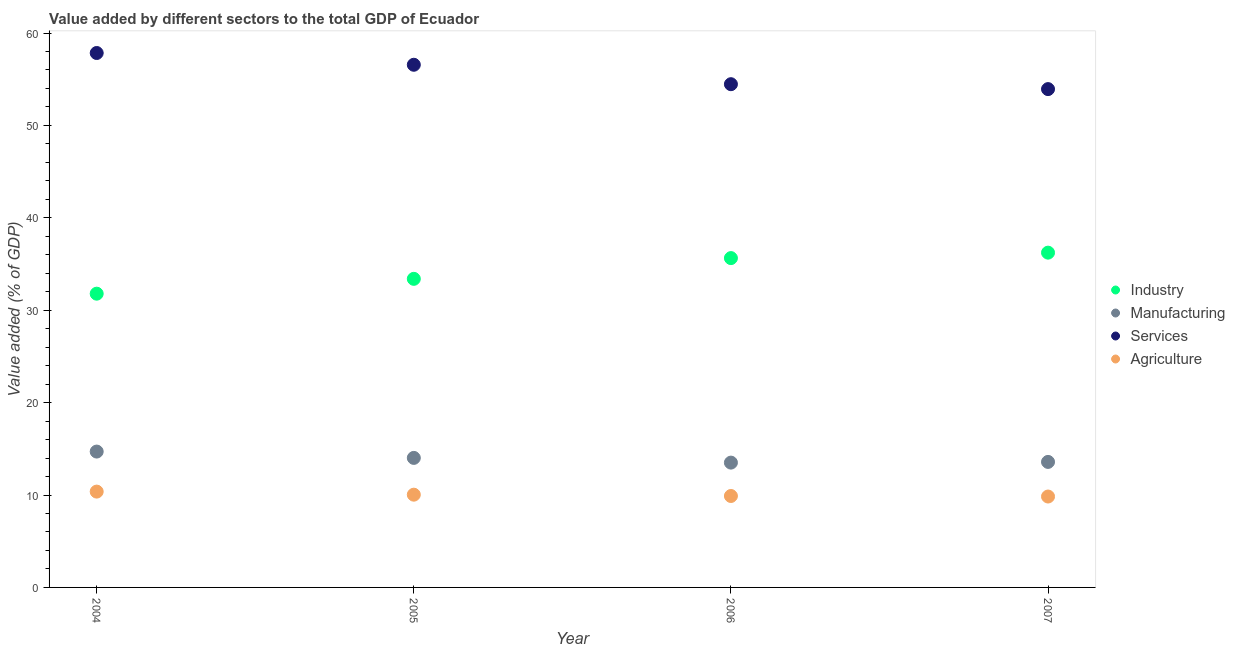What is the value added by agricultural sector in 2004?
Your answer should be compact. 10.37. Across all years, what is the maximum value added by services sector?
Offer a terse response. 57.84. Across all years, what is the minimum value added by agricultural sector?
Offer a very short reply. 9.84. In which year was the value added by services sector maximum?
Offer a terse response. 2004. What is the total value added by services sector in the graph?
Provide a short and direct response. 222.8. What is the difference between the value added by industrial sector in 2004 and that in 2005?
Your answer should be compact. -1.61. What is the difference between the value added by agricultural sector in 2005 and the value added by industrial sector in 2004?
Give a very brief answer. -21.75. What is the average value added by manufacturing sector per year?
Your answer should be compact. 13.95. In the year 2007, what is the difference between the value added by industrial sector and value added by services sector?
Provide a short and direct response. -17.7. In how many years, is the value added by services sector greater than 18 %?
Keep it short and to the point. 4. What is the ratio of the value added by manufacturing sector in 2006 to that in 2007?
Your response must be concise. 0.99. What is the difference between the highest and the second highest value added by manufacturing sector?
Give a very brief answer. 0.69. What is the difference between the highest and the lowest value added by manufacturing sector?
Your answer should be compact. 1.2. In how many years, is the value added by services sector greater than the average value added by services sector taken over all years?
Keep it short and to the point. 2. Is the sum of the value added by services sector in 2004 and 2006 greater than the maximum value added by agricultural sector across all years?
Provide a short and direct response. Yes. Is it the case that in every year, the sum of the value added by manufacturing sector and value added by services sector is greater than the sum of value added by industrial sector and value added by agricultural sector?
Give a very brief answer. No. Is the value added by agricultural sector strictly greater than the value added by manufacturing sector over the years?
Give a very brief answer. No. Is the value added by industrial sector strictly less than the value added by agricultural sector over the years?
Your response must be concise. No. How many years are there in the graph?
Offer a very short reply. 4. Does the graph contain grids?
Make the answer very short. No. How many legend labels are there?
Keep it short and to the point. 4. How are the legend labels stacked?
Keep it short and to the point. Vertical. What is the title of the graph?
Offer a terse response. Value added by different sectors to the total GDP of Ecuador. Does "UNPBF" appear as one of the legend labels in the graph?
Your answer should be compact. No. What is the label or title of the Y-axis?
Provide a succinct answer. Value added (% of GDP). What is the Value added (% of GDP) of Industry in 2004?
Keep it short and to the point. 31.79. What is the Value added (% of GDP) in Manufacturing in 2004?
Your answer should be very brief. 14.7. What is the Value added (% of GDP) of Services in 2004?
Make the answer very short. 57.84. What is the Value added (% of GDP) of Agriculture in 2004?
Give a very brief answer. 10.37. What is the Value added (% of GDP) in Industry in 2005?
Ensure brevity in your answer.  33.4. What is the Value added (% of GDP) in Manufacturing in 2005?
Your answer should be compact. 14.02. What is the Value added (% of GDP) of Services in 2005?
Ensure brevity in your answer.  56.57. What is the Value added (% of GDP) of Agriculture in 2005?
Your answer should be very brief. 10.04. What is the Value added (% of GDP) in Industry in 2006?
Your answer should be very brief. 35.64. What is the Value added (% of GDP) of Manufacturing in 2006?
Make the answer very short. 13.51. What is the Value added (% of GDP) in Services in 2006?
Provide a succinct answer. 54.46. What is the Value added (% of GDP) of Agriculture in 2006?
Provide a short and direct response. 9.9. What is the Value added (% of GDP) in Industry in 2007?
Ensure brevity in your answer.  36.23. What is the Value added (% of GDP) in Manufacturing in 2007?
Provide a succinct answer. 13.58. What is the Value added (% of GDP) of Services in 2007?
Ensure brevity in your answer.  53.93. What is the Value added (% of GDP) of Agriculture in 2007?
Offer a very short reply. 9.84. Across all years, what is the maximum Value added (% of GDP) in Industry?
Your response must be concise. 36.23. Across all years, what is the maximum Value added (% of GDP) of Manufacturing?
Offer a very short reply. 14.7. Across all years, what is the maximum Value added (% of GDP) of Services?
Give a very brief answer. 57.84. Across all years, what is the maximum Value added (% of GDP) in Agriculture?
Your answer should be compact. 10.37. Across all years, what is the minimum Value added (% of GDP) in Industry?
Your answer should be very brief. 31.79. Across all years, what is the minimum Value added (% of GDP) in Manufacturing?
Your answer should be compact. 13.51. Across all years, what is the minimum Value added (% of GDP) of Services?
Your answer should be compact. 53.93. Across all years, what is the minimum Value added (% of GDP) in Agriculture?
Your answer should be very brief. 9.84. What is the total Value added (% of GDP) of Industry in the graph?
Make the answer very short. 137.06. What is the total Value added (% of GDP) of Manufacturing in the graph?
Provide a succinct answer. 55.81. What is the total Value added (% of GDP) of Services in the graph?
Your answer should be very brief. 222.8. What is the total Value added (% of GDP) of Agriculture in the graph?
Keep it short and to the point. 40.14. What is the difference between the Value added (% of GDP) of Industry in 2004 and that in 2005?
Offer a very short reply. -1.61. What is the difference between the Value added (% of GDP) in Manufacturing in 2004 and that in 2005?
Provide a succinct answer. 0.69. What is the difference between the Value added (% of GDP) of Services in 2004 and that in 2005?
Your response must be concise. 1.27. What is the difference between the Value added (% of GDP) of Agriculture in 2004 and that in 2005?
Make the answer very short. 0.33. What is the difference between the Value added (% of GDP) of Industry in 2004 and that in 2006?
Offer a very short reply. -3.85. What is the difference between the Value added (% of GDP) in Manufacturing in 2004 and that in 2006?
Give a very brief answer. 1.2. What is the difference between the Value added (% of GDP) in Services in 2004 and that in 2006?
Give a very brief answer. 3.38. What is the difference between the Value added (% of GDP) of Agriculture in 2004 and that in 2006?
Give a very brief answer. 0.47. What is the difference between the Value added (% of GDP) in Industry in 2004 and that in 2007?
Ensure brevity in your answer.  -4.44. What is the difference between the Value added (% of GDP) in Manufacturing in 2004 and that in 2007?
Offer a terse response. 1.12. What is the difference between the Value added (% of GDP) of Services in 2004 and that in 2007?
Offer a terse response. 3.91. What is the difference between the Value added (% of GDP) in Agriculture in 2004 and that in 2007?
Your answer should be very brief. 0.53. What is the difference between the Value added (% of GDP) in Industry in 2005 and that in 2006?
Give a very brief answer. -2.25. What is the difference between the Value added (% of GDP) of Manufacturing in 2005 and that in 2006?
Ensure brevity in your answer.  0.51. What is the difference between the Value added (% of GDP) in Services in 2005 and that in 2006?
Provide a short and direct response. 2.1. What is the difference between the Value added (% of GDP) in Agriculture in 2005 and that in 2006?
Your answer should be compact. 0.14. What is the difference between the Value added (% of GDP) in Industry in 2005 and that in 2007?
Ensure brevity in your answer.  -2.83. What is the difference between the Value added (% of GDP) in Manufacturing in 2005 and that in 2007?
Make the answer very short. 0.43. What is the difference between the Value added (% of GDP) in Services in 2005 and that in 2007?
Provide a short and direct response. 2.63. What is the difference between the Value added (% of GDP) in Agriculture in 2005 and that in 2007?
Your answer should be compact. 0.2. What is the difference between the Value added (% of GDP) in Industry in 2006 and that in 2007?
Give a very brief answer. -0.59. What is the difference between the Value added (% of GDP) in Manufacturing in 2006 and that in 2007?
Give a very brief answer. -0.08. What is the difference between the Value added (% of GDP) in Services in 2006 and that in 2007?
Offer a very short reply. 0.53. What is the difference between the Value added (% of GDP) in Agriculture in 2006 and that in 2007?
Give a very brief answer. 0.06. What is the difference between the Value added (% of GDP) in Industry in 2004 and the Value added (% of GDP) in Manufacturing in 2005?
Give a very brief answer. 17.77. What is the difference between the Value added (% of GDP) in Industry in 2004 and the Value added (% of GDP) in Services in 2005?
Your answer should be very brief. -24.77. What is the difference between the Value added (% of GDP) in Industry in 2004 and the Value added (% of GDP) in Agriculture in 2005?
Provide a succinct answer. 21.75. What is the difference between the Value added (% of GDP) in Manufacturing in 2004 and the Value added (% of GDP) in Services in 2005?
Your answer should be compact. -41.86. What is the difference between the Value added (% of GDP) of Manufacturing in 2004 and the Value added (% of GDP) of Agriculture in 2005?
Offer a terse response. 4.67. What is the difference between the Value added (% of GDP) in Services in 2004 and the Value added (% of GDP) in Agriculture in 2005?
Offer a terse response. 47.8. What is the difference between the Value added (% of GDP) in Industry in 2004 and the Value added (% of GDP) in Manufacturing in 2006?
Make the answer very short. 18.28. What is the difference between the Value added (% of GDP) of Industry in 2004 and the Value added (% of GDP) of Services in 2006?
Make the answer very short. -22.67. What is the difference between the Value added (% of GDP) of Industry in 2004 and the Value added (% of GDP) of Agriculture in 2006?
Your response must be concise. 21.9. What is the difference between the Value added (% of GDP) in Manufacturing in 2004 and the Value added (% of GDP) in Services in 2006?
Provide a succinct answer. -39.76. What is the difference between the Value added (% of GDP) of Manufacturing in 2004 and the Value added (% of GDP) of Agriculture in 2006?
Keep it short and to the point. 4.81. What is the difference between the Value added (% of GDP) of Services in 2004 and the Value added (% of GDP) of Agriculture in 2006?
Your answer should be compact. 47.94. What is the difference between the Value added (% of GDP) in Industry in 2004 and the Value added (% of GDP) in Manufacturing in 2007?
Make the answer very short. 18.21. What is the difference between the Value added (% of GDP) in Industry in 2004 and the Value added (% of GDP) in Services in 2007?
Provide a succinct answer. -22.14. What is the difference between the Value added (% of GDP) in Industry in 2004 and the Value added (% of GDP) in Agriculture in 2007?
Give a very brief answer. 21.95. What is the difference between the Value added (% of GDP) of Manufacturing in 2004 and the Value added (% of GDP) of Services in 2007?
Provide a short and direct response. -39.23. What is the difference between the Value added (% of GDP) of Manufacturing in 2004 and the Value added (% of GDP) of Agriculture in 2007?
Keep it short and to the point. 4.87. What is the difference between the Value added (% of GDP) in Services in 2004 and the Value added (% of GDP) in Agriculture in 2007?
Ensure brevity in your answer.  48. What is the difference between the Value added (% of GDP) in Industry in 2005 and the Value added (% of GDP) in Manufacturing in 2006?
Offer a terse response. 19.89. What is the difference between the Value added (% of GDP) of Industry in 2005 and the Value added (% of GDP) of Services in 2006?
Your answer should be compact. -21.07. What is the difference between the Value added (% of GDP) of Industry in 2005 and the Value added (% of GDP) of Agriculture in 2006?
Your answer should be compact. 23.5. What is the difference between the Value added (% of GDP) in Manufacturing in 2005 and the Value added (% of GDP) in Services in 2006?
Your response must be concise. -40.44. What is the difference between the Value added (% of GDP) of Manufacturing in 2005 and the Value added (% of GDP) of Agriculture in 2006?
Keep it short and to the point. 4.12. What is the difference between the Value added (% of GDP) in Services in 2005 and the Value added (% of GDP) in Agriculture in 2006?
Provide a succinct answer. 46.67. What is the difference between the Value added (% of GDP) in Industry in 2005 and the Value added (% of GDP) in Manufacturing in 2007?
Keep it short and to the point. 19.81. What is the difference between the Value added (% of GDP) of Industry in 2005 and the Value added (% of GDP) of Services in 2007?
Keep it short and to the point. -20.53. What is the difference between the Value added (% of GDP) in Industry in 2005 and the Value added (% of GDP) in Agriculture in 2007?
Ensure brevity in your answer.  23.56. What is the difference between the Value added (% of GDP) of Manufacturing in 2005 and the Value added (% of GDP) of Services in 2007?
Provide a succinct answer. -39.91. What is the difference between the Value added (% of GDP) of Manufacturing in 2005 and the Value added (% of GDP) of Agriculture in 2007?
Your answer should be very brief. 4.18. What is the difference between the Value added (% of GDP) in Services in 2005 and the Value added (% of GDP) in Agriculture in 2007?
Ensure brevity in your answer.  46.73. What is the difference between the Value added (% of GDP) of Industry in 2006 and the Value added (% of GDP) of Manufacturing in 2007?
Give a very brief answer. 22.06. What is the difference between the Value added (% of GDP) of Industry in 2006 and the Value added (% of GDP) of Services in 2007?
Make the answer very short. -18.29. What is the difference between the Value added (% of GDP) in Industry in 2006 and the Value added (% of GDP) in Agriculture in 2007?
Ensure brevity in your answer.  25.8. What is the difference between the Value added (% of GDP) of Manufacturing in 2006 and the Value added (% of GDP) of Services in 2007?
Provide a short and direct response. -40.42. What is the difference between the Value added (% of GDP) in Manufacturing in 2006 and the Value added (% of GDP) in Agriculture in 2007?
Ensure brevity in your answer.  3.67. What is the difference between the Value added (% of GDP) of Services in 2006 and the Value added (% of GDP) of Agriculture in 2007?
Give a very brief answer. 44.63. What is the average Value added (% of GDP) in Industry per year?
Your response must be concise. 34.27. What is the average Value added (% of GDP) of Manufacturing per year?
Provide a short and direct response. 13.95. What is the average Value added (% of GDP) of Services per year?
Offer a very short reply. 55.7. What is the average Value added (% of GDP) of Agriculture per year?
Make the answer very short. 10.04. In the year 2004, what is the difference between the Value added (% of GDP) of Industry and Value added (% of GDP) of Manufacturing?
Offer a very short reply. 17.09. In the year 2004, what is the difference between the Value added (% of GDP) in Industry and Value added (% of GDP) in Services?
Provide a short and direct response. -26.05. In the year 2004, what is the difference between the Value added (% of GDP) of Industry and Value added (% of GDP) of Agriculture?
Offer a very short reply. 21.42. In the year 2004, what is the difference between the Value added (% of GDP) in Manufacturing and Value added (% of GDP) in Services?
Offer a terse response. -43.13. In the year 2004, what is the difference between the Value added (% of GDP) in Manufacturing and Value added (% of GDP) in Agriculture?
Keep it short and to the point. 4.33. In the year 2004, what is the difference between the Value added (% of GDP) of Services and Value added (% of GDP) of Agriculture?
Give a very brief answer. 47.47. In the year 2005, what is the difference between the Value added (% of GDP) of Industry and Value added (% of GDP) of Manufacturing?
Keep it short and to the point. 19.38. In the year 2005, what is the difference between the Value added (% of GDP) of Industry and Value added (% of GDP) of Services?
Offer a very short reply. -23.17. In the year 2005, what is the difference between the Value added (% of GDP) in Industry and Value added (% of GDP) in Agriculture?
Your answer should be very brief. 23.36. In the year 2005, what is the difference between the Value added (% of GDP) in Manufacturing and Value added (% of GDP) in Services?
Your response must be concise. -42.55. In the year 2005, what is the difference between the Value added (% of GDP) in Manufacturing and Value added (% of GDP) in Agriculture?
Your answer should be compact. 3.98. In the year 2005, what is the difference between the Value added (% of GDP) of Services and Value added (% of GDP) of Agriculture?
Provide a succinct answer. 46.53. In the year 2006, what is the difference between the Value added (% of GDP) of Industry and Value added (% of GDP) of Manufacturing?
Provide a succinct answer. 22.13. In the year 2006, what is the difference between the Value added (% of GDP) in Industry and Value added (% of GDP) in Services?
Make the answer very short. -18.82. In the year 2006, what is the difference between the Value added (% of GDP) of Industry and Value added (% of GDP) of Agriculture?
Offer a very short reply. 25.75. In the year 2006, what is the difference between the Value added (% of GDP) in Manufacturing and Value added (% of GDP) in Services?
Provide a short and direct response. -40.95. In the year 2006, what is the difference between the Value added (% of GDP) in Manufacturing and Value added (% of GDP) in Agriculture?
Your response must be concise. 3.61. In the year 2006, what is the difference between the Value added (% of GDP) in Services and Value added (% of GDP) in Agriculture?
Your answer should be compact. 44.57. In the year 2007, what is the difference between the Value added (% of GDP) in Industry and Value added (% of GDP) in Manufacturing?
Your answer should be very brief. 22.65. In the year 2007, what is the difference between the Value added (% of GDP) in Industry and Value added (% of GDP) in Services?
Your answer should be very brief. -17.7. In the year 2007, what is the difference between the Value added (% of GDP) of Industry and Value added (% of GDP) of Agriculture?
Provide a succinct answer. 26.39. In the year 2007, what is the difference between the Value added (% of GDP) of Manufacturing and Value added (% of GDP) of Services?
Your answer should be very brief. -40.35. In the year 2007, what is the difference between the Value added (% of GDP) in Manufacturing and Value added (% of GDP) in Agriculture?
Make the answer very short. 3.75. In the year 2007, what is the difference between the Value added (% of GDP) in Services and Value added (% of GDP) in Agriculture?
Give a very brief answer. 44.09. What is the ratio of the Value added (% of GDP) of Industry in 2004 to that in 2005?
Provide a succinct answer. 0.95. What is the ratio of the Value added (% of GDP) of Manufacturing in 2004 to that in 2005?
Make the answer very short. 1.05. What is the ratio of the Value added (% of GDP) in Services in 2004 to that in 2005?
Your answer should be compact. 1.02. What is the ratio of the Value added (% of GDP) in Agriculture in 2004 to that in 2005?
Your answer should be very brief. 1.03. What is the ratio of the Value added (% of GDP) of Industry in 2004 to that in 2006?
Keep it short and to the point. 0.89. What is the ratio of the Value added (% of GDP) of Manufacturing in 2004 to that in 2006?
Offer a very short reply. 1.09. What is the ratio of the Value added (% of GDP) of Services in 2004 to that in 2006?
Keep it short and to the point. 1.06. What is the ratio of the Value added (% of GDP) in Agriculture in 2004 to that in 2006?
Keep it short and to the point. 1.05. What is the ratio of the Value added (% of GDP) of Industry in 2004 to that in 2007?
Provide a succinct answer. 0.88. What is the ratio of the Value added (% of GDP) in Manufacturing in 2004 to that in 2007?
Your response must be concise. 1.08. What is the ratio of the Value added (% of GDP) in Services in 2004 to that in 2007?
Give a very brief answer. 1.07. What is the ratio of the Value added (% of GDP) of Agriculture in 2004 to that in 2007?
Your answer should be very brief. 1.05. What is the ratio of the Value added (% of GDP) of Industry in 2005 to that in 2006?
Keep it short and to the point. 0.94. What is the ratio of the Value added (% of GDP) in Manufacturing in 2005 to that in 2006?
Keep it short and to the point. 1.04. What is the ratio of the Value added (% of GDP) of Services in 2005 to that in 2006?
Your answer should be very brief. 1.04. What is the ratio of the Value added (% of GDP) of Agriculture in 2005 to that in 2006?
Your answer should be compact. 1.01. What is the ratio of the Value added (% of GDP) in Industry in 2005 to that in 2007?
Your answer should be very brief. 0.92. What is the ratio of the Value added (% of GDP) of Manufacturing in 2005 to that in 2007?
Provide a short and direct response. 1.03. What is the ratio of the Value added (% of GDP) in Services in 2005 to that in 2007?
Provide a succinct answer. 1.05. What is the ratio of the Value added (% of GDP) in Agriculture in 2005 to that in 2007?
Make the answer very short. 1.02. What is the ratio of the Value added (% of GDP) of Industry in 2006 to that in 2007?
Offer a terse response. 0.98. What is the ratio of the Value added (% of GDP) of Manufacturing in 2006 to that in 2007?
Offer a very short reply. 0.99. What is the ratio of the Value added (% of GDP) in Services in 2006 to that in 2007?
Offer a terse response. 1.01. What is the ratio of the Value added (% of GDP) in Agriculture in 2006 to that in 2007?
Offer a very short reply. 1.01. What is the difference between the highest and the second highest Value added (% of GDP) in Industry?
Ensure brevity in your answer.  0.59. What is the difference between the highest and the second highest Value added (% of GDP) of Manufacturing?
Provide a short and direct response. 0.69. What is the difference between the highest and the second highest Value added (% of GDP) in Services?
Provide a succinct answer. 1.27. What is the difference between the highest and the second highest Value added (% of GDP) of Agriculture?
Offer a terse response. 0.33. What is the difference between the highest and the lowest Value added (% of GDP) of Industry?
Your response must be concise. 4.44. What is the difference between the highest and the lowest Value added (% of GDP) in Manufacturing?
Provide a succinct answer. 1.2. What is the difference between the highest and the lowest Value added (% of GDP) of Services?
Make the answer very short. 3.91. What is the difference between the highest and the lowest Value added (% of GDP) in Agriculture?
Make the answer very short. 0.53. 